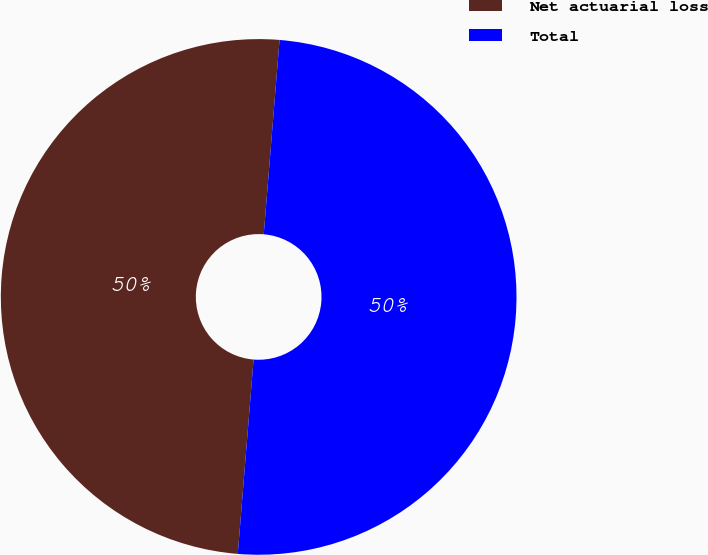<chart> <loc_0><loc_0><loc_500><loc_500><pie_chart><fcel>Net actuarial loss<fcel>Total<nl><fcel>50.0%<fcel>50.0%<nl></chart> 